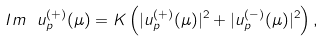Convert formula to latex. <formula><loc_0><loc_0><loc_500><loc_500>I m \ u _ { p } ^ { ( + ) } ( \mu ) = K \left ( | u _ { p } ^ { ( + ) } ( \mu ) | ^ { 2 } + | u _ { p } ^ { ( - ) } ( \mu ) | ^ { 2 } \right ) ,</formula> 